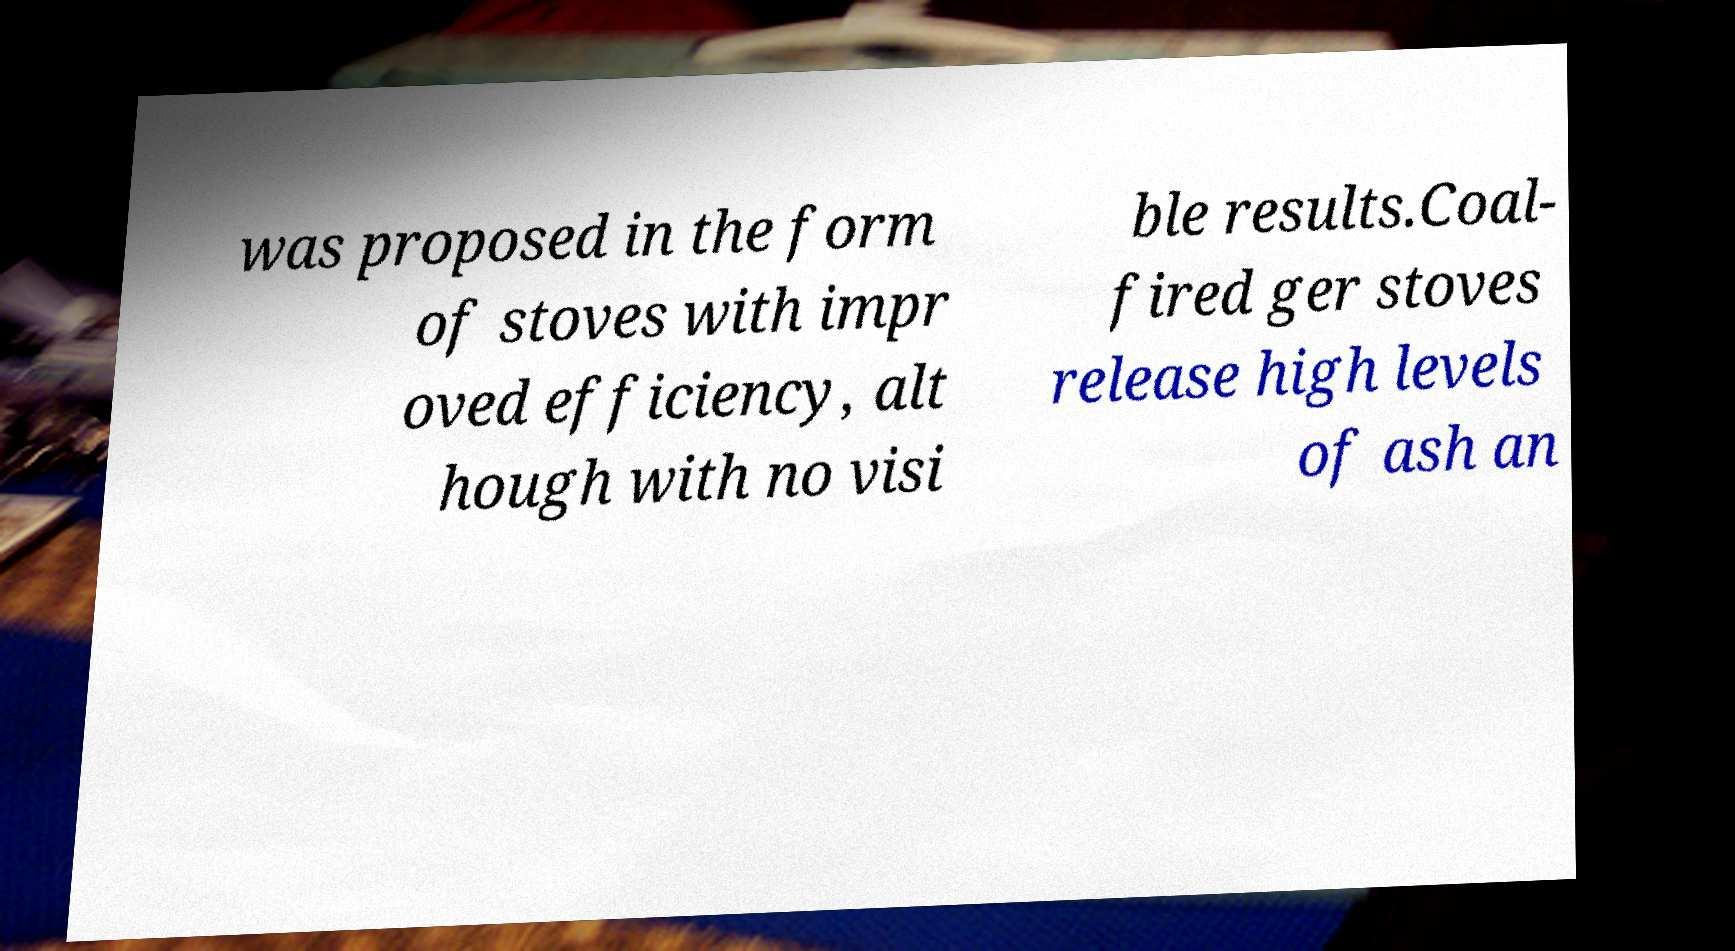Please identify and transcribe the text found in this image. was proposed in the form of stoves with impr oved efficiency, alt hough with no visi ble results.Coal- fired ger stoves release high levels of ash an 